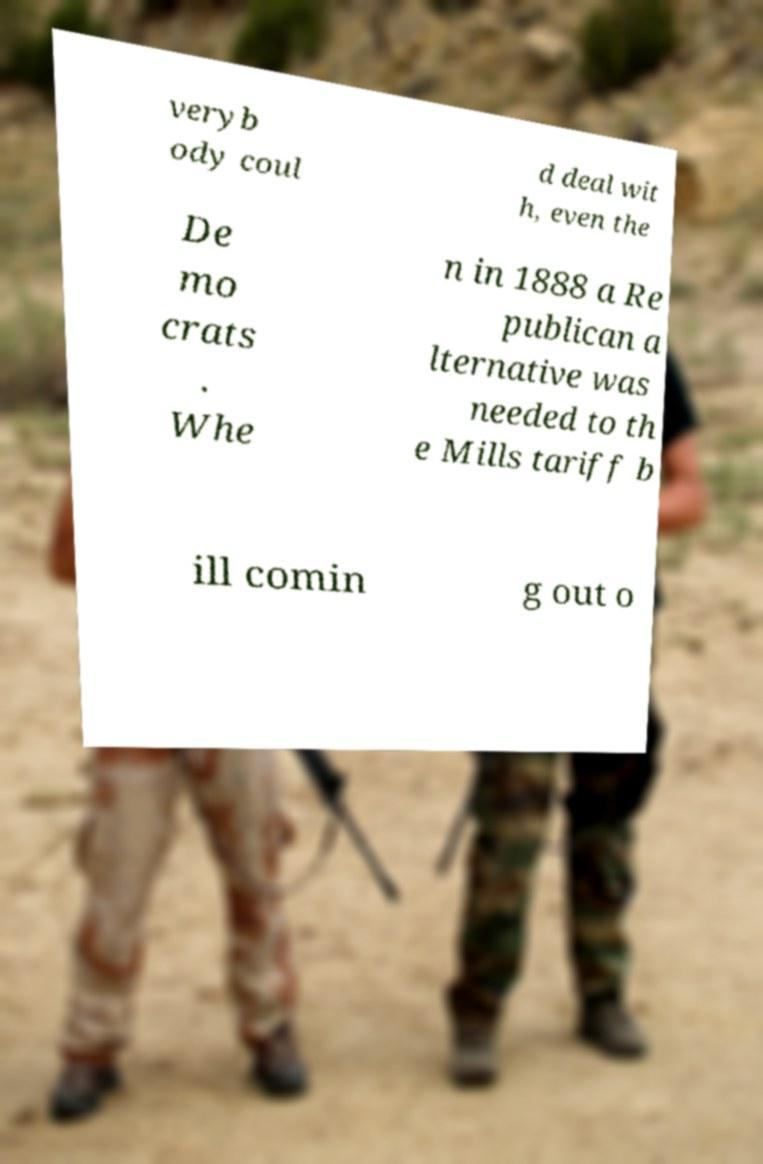There's text embedded in this image that I need extracted. Can you transcribe it verbatim? veryb ody coul d deal wit h, even the De mo crats . Whe n in 1888 a Re publican a lternative was needed to th e Mills tariff b ill comin g out o 